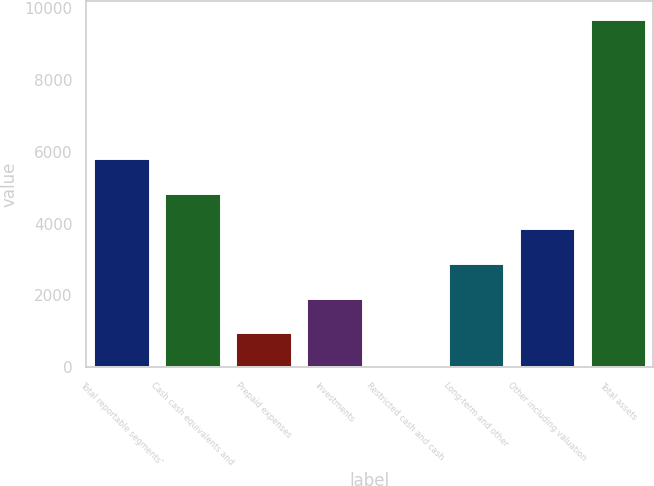<chart> <loc_0><loc_0><loc_500><loc_500><bar_chart><fcel>Total reportable segments'<fcel>Cash cash equivalents and<fcel>Prepaid expenses<fcel>Investments<fcel>Restricted cash and cash<fcel>Long-term and other<fcel>Other including valuation<fcel>Total assets<nl><fcel>5820<fcel>4851<fcel>975<fcel>1944<fcel>6<fcel>2913<fcel>3882<fcel>9696<nl></chart> 